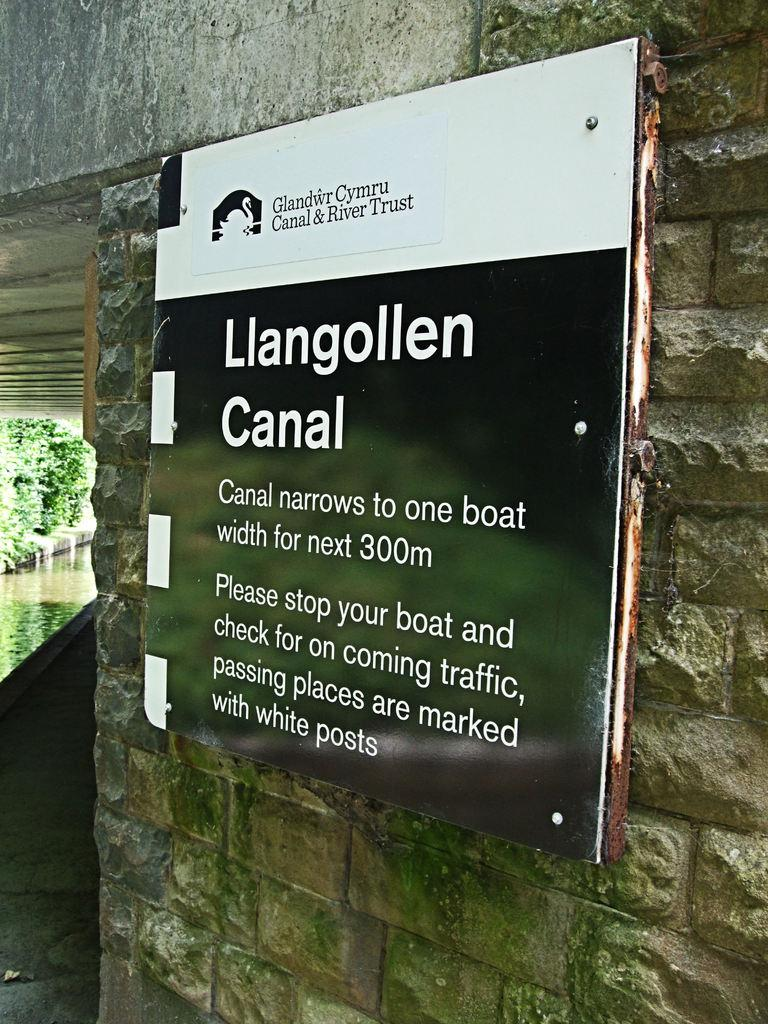What is the main object in the image? There is a banner board in the image. Where is the banner board located? The banner board is placed on a wall. What type of breakfast is being served on the banner board in the image? There is no breakfast or food depicted on the banner board in the image. What is the income of the person who created the banner board in the image? There is no information about the creator of the banner board or their income in the image. 